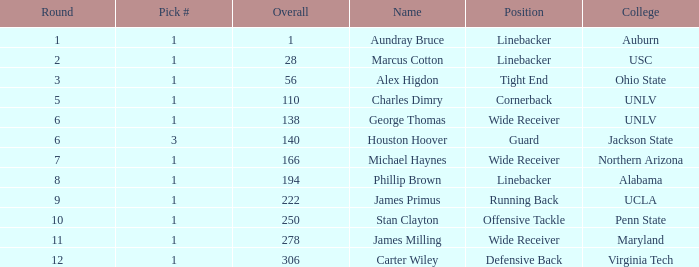In what Round was George Thomas Picked? 6.0. 